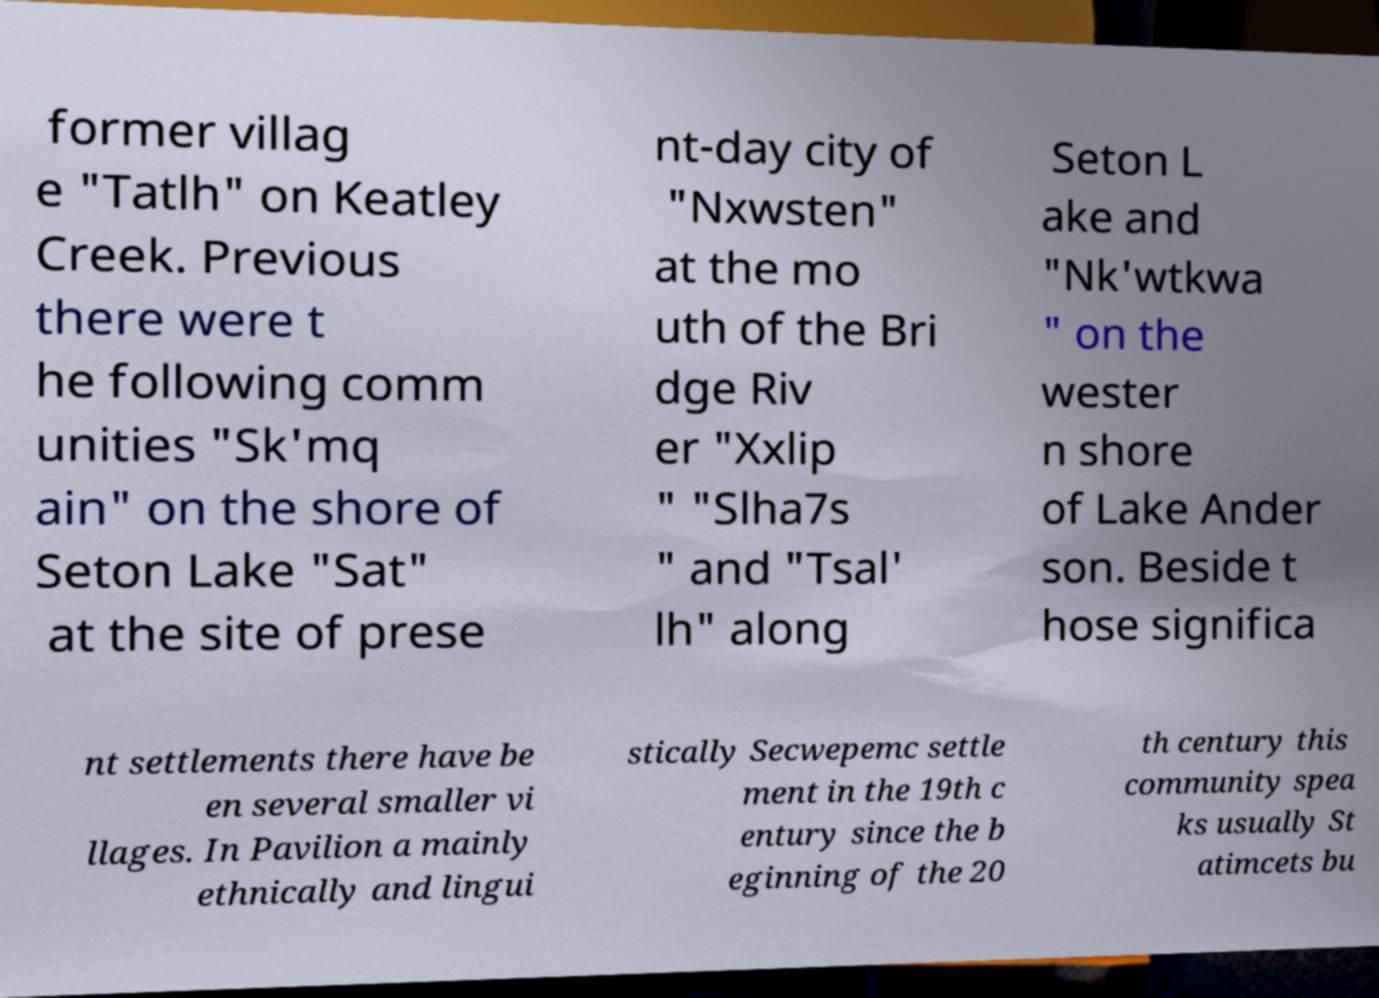Could you extract and type out the text from this image? former villag e "Tatlh" on Keatley Creek. Previous there were t he following comm unities "Sk'mq ain" on the shore of Seton Lake "Sat" at the site of prese nt-day city of "Nxwsten" at the mo uth of the Bri dge Riv er "Xxlip " "Slha7s " and "Tsal' lh" along Seton L ake and "Nk'wtkwa " on the wester n shore of Lake Ander son. Beside t hose significa nt settlements there have be en several smaller vi llages. In Pavilion a mainly ethnically and lingui stically Secwepemc settle ment in the 19th c entury since the b eginning of the 20 th century this community spea ks usually St atimcets bu 